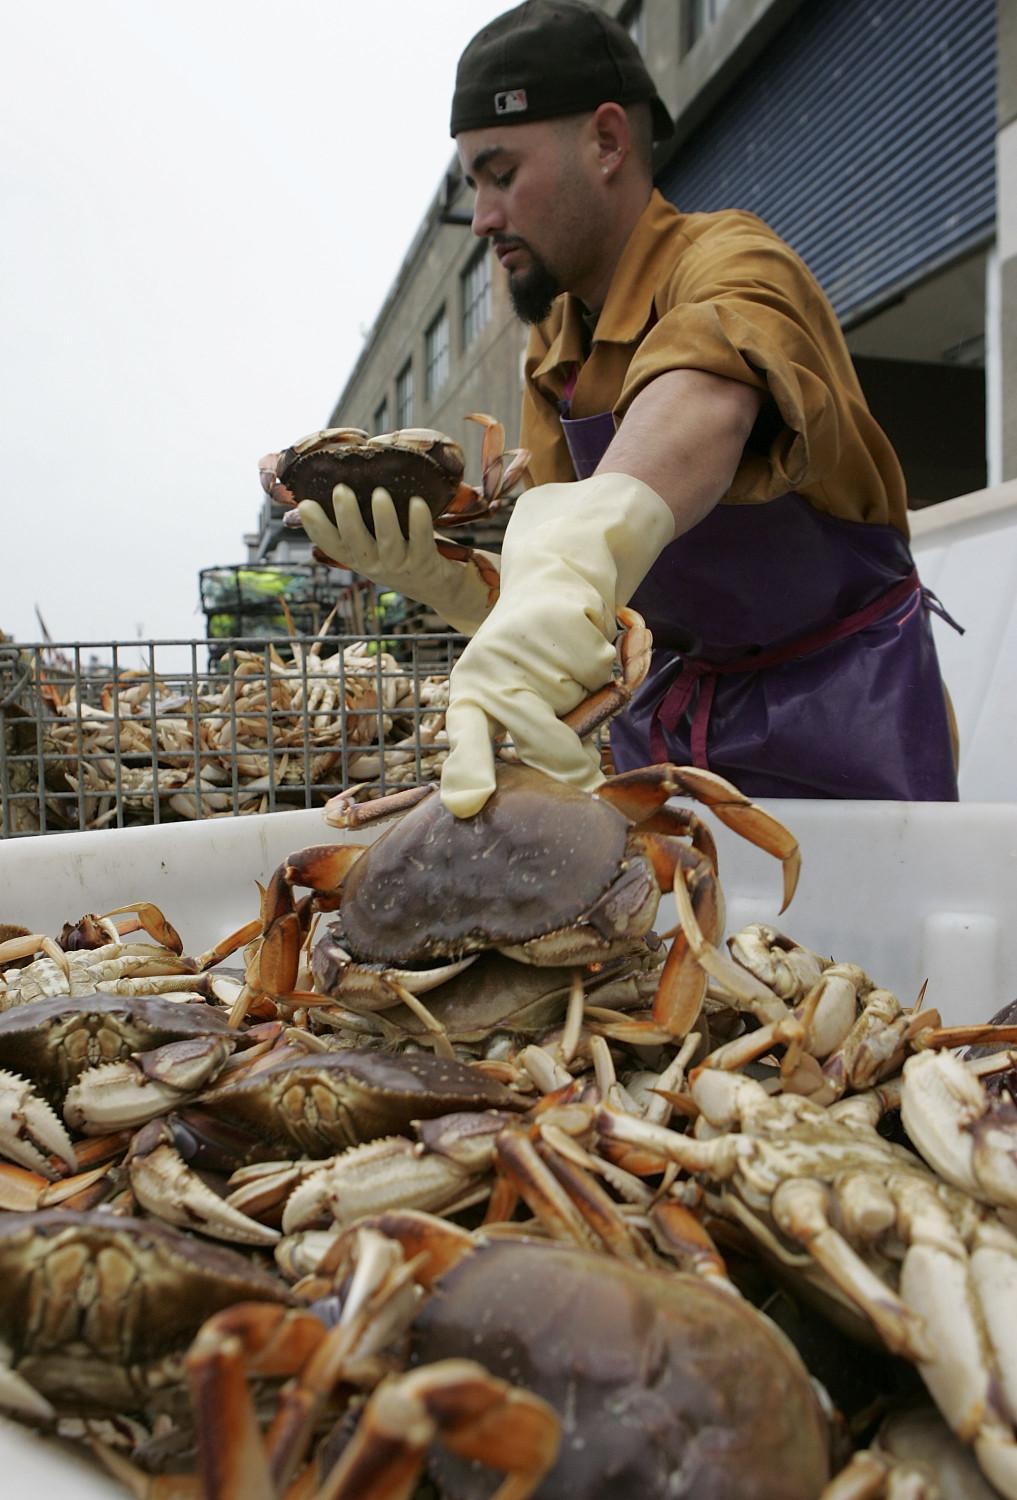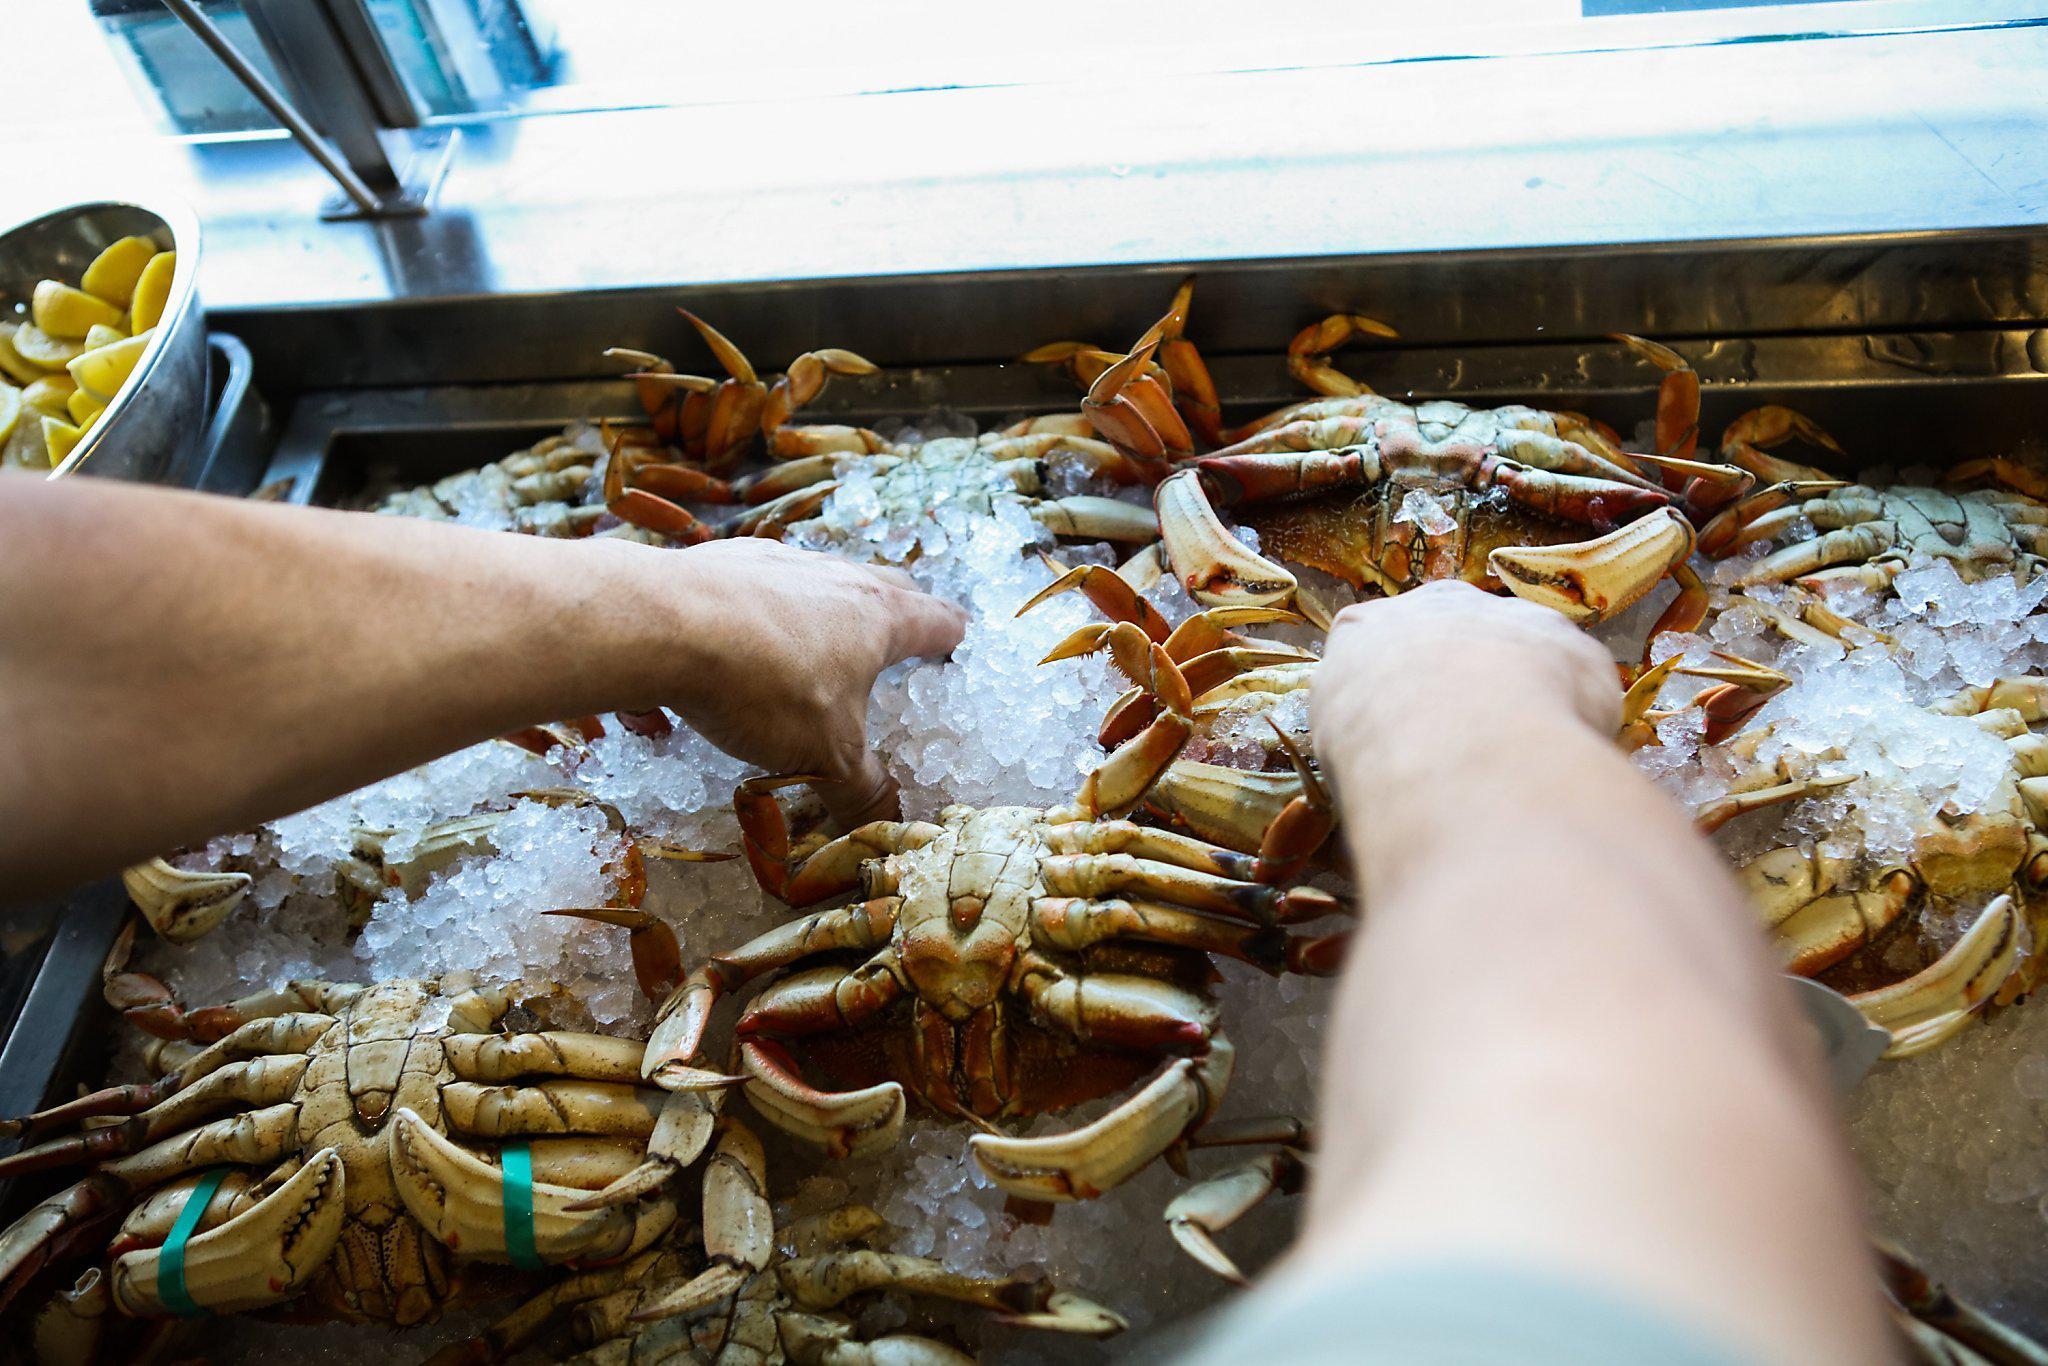The first image is the image on the left, the second image is the image on the right. Given the left and right images, does the statement "In the right image, a man is holding a crab up belly-side forward in one bare hand." hold true? Answer yes or no. No. 